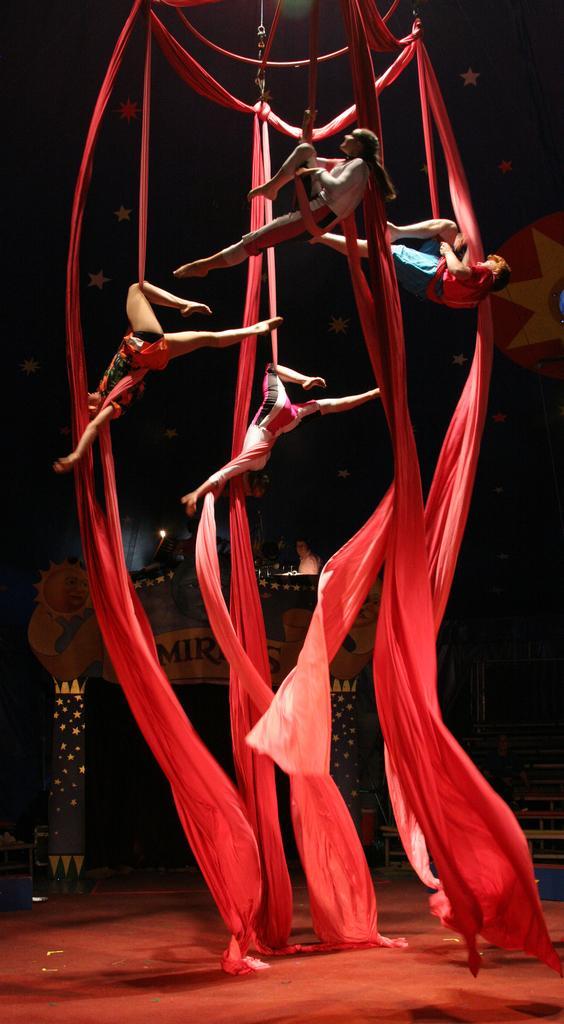How would you summarize this image in a sentence or two? This picture consists of static trapeze in the image and there are stars and a decorated arch in the image. 